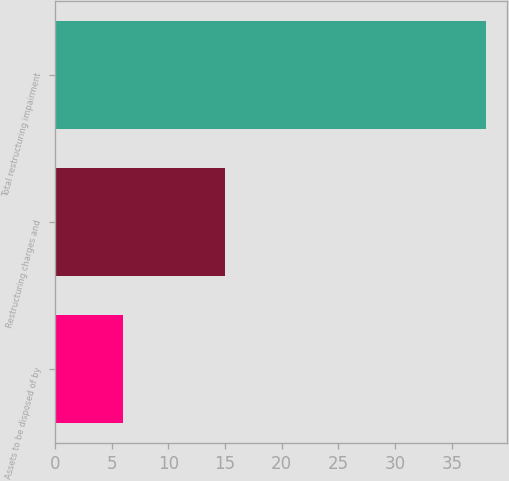Convert chart to OTSL. <chart><loc_0><loc_0><loc_500><loc_500><bar_chart><fcel>Assets to be disposed of by<fcel>Restructuring charges and<fcel>Total restructuring impairment<nl><fcel>6<fcel>15<fcel>38<nl></chart> 